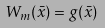<formula> <loc_0><loc_0><loc_500><loc_500>W _ { m } ( \bar { x } ) = g ( \bar { x } )</formula> 